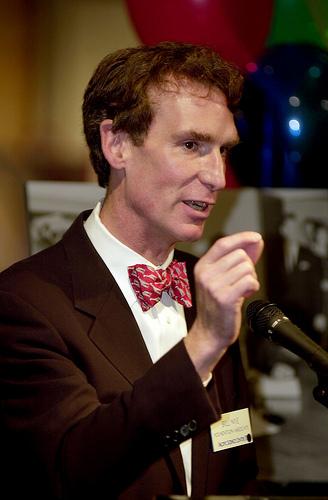What is the man doing at the microphone?
Quick response, please. Talking. Why is the man speaking at the microphone?
Write a very short answer. Speech. Who is this famous person?
Give a very brief answer. Bill nye. 